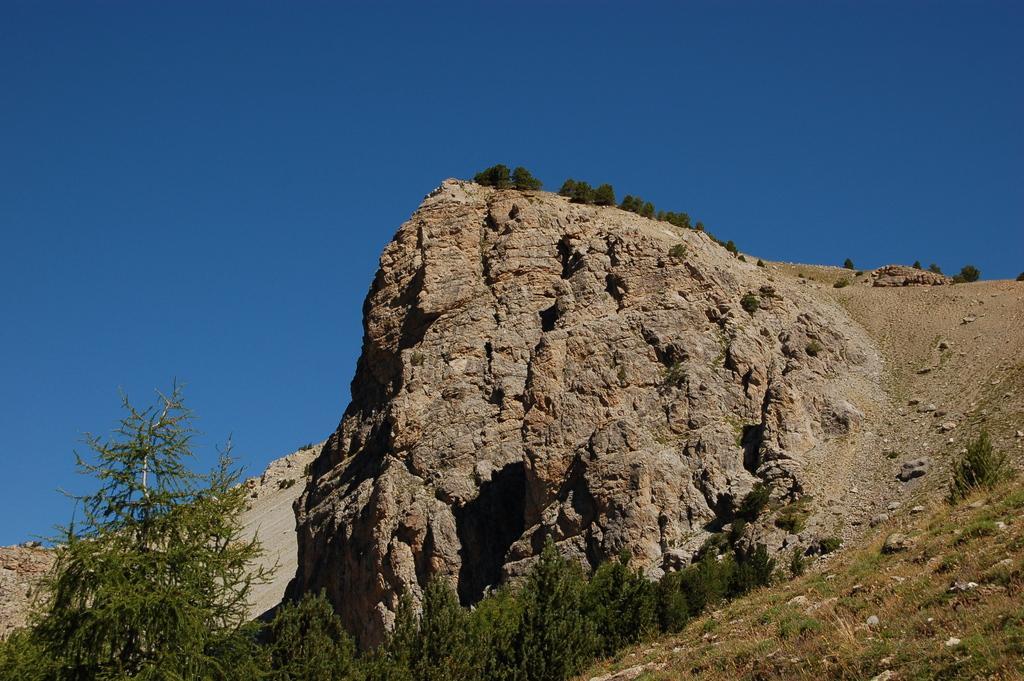Can you describe this image briefly? In this image we can see a mountain. On the mountain we can see few trees. At the bottom we can see a group of trees and plants. At the top we can see the clear sky. 